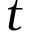Convert formula to latex. <formula><loc_0><loc_0><loc_500><loc_500>t</formula> 